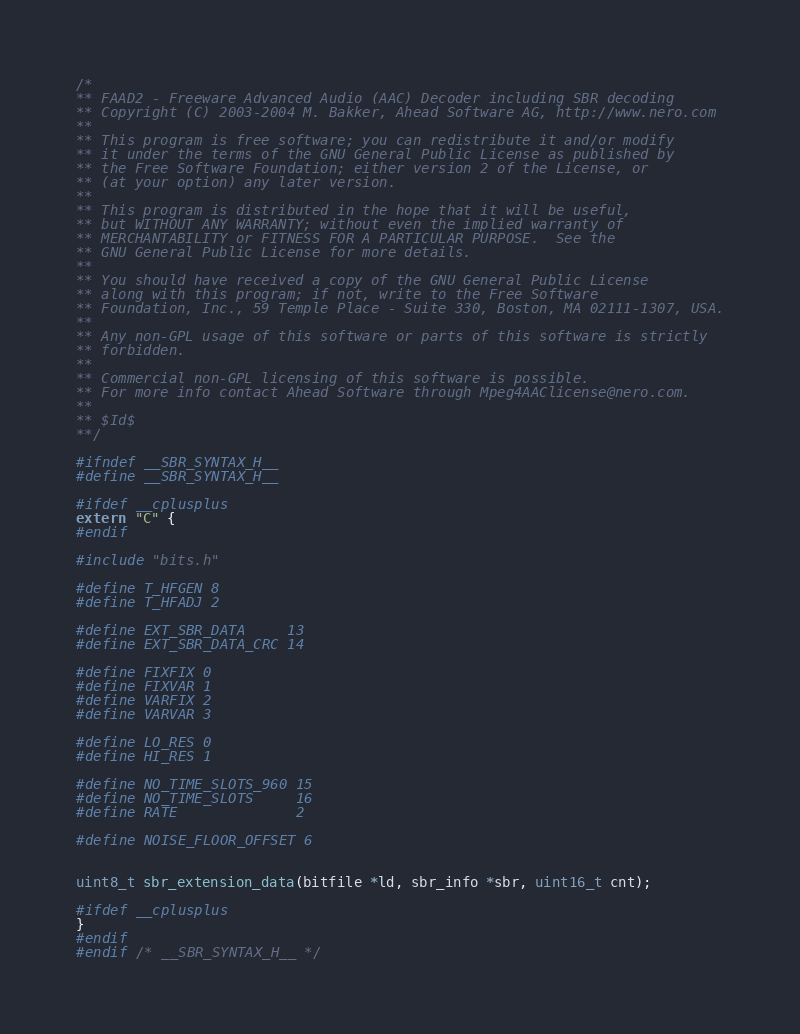<code> <loc_0><loc_0><loc_500><loc_500><_C_>/*
** FAAD2 - Freeware Advanced Audio (AAC) Decoder including SBR decoding
** Copyright (C) 2003-2004 M. Bakker, Ahead Software AG, http://www.nero.com
**  
** This program is free software; you can redistribute it and/or modify
** it under the terms of the GNU General Public License as published by
** the Free Software Foundation; either version 2 of the License, or
** (at your option) any later version.
** 
** This program is distributed in the hope that it will be useful,
** but WITHOUT ANY WARRANTY; without even the implied warranty of
** MERCHANTABILITY or FITNESS FOR A PARTICULAR PURPOSE.  See the
** GNU General Public License for more details.
** 
** You should have received a copy of the GNU General Public License
** along with this program; if not, write to the Free Software 
** Foundation, Inc., 59 Temple Place - Suite 330, Boston, MA 02111-1307, USA.
**
** Any non-GPL usage of this software or parts of this software is strictly
** forbidden.
**
** Commercial non-GPL licensing of this software is possible.
** For more info contact Ahead Software through Mpeg4AAClicense@nero.com.
**
** $Id$
**/

#ifndef __SBR_SYNTAX_H__
#define __SBR_SYNTAX_H__

#ifdef __cplusplus
extern "C" {
#endif

#include "bits.h"

#define T_HFGEN 8
#define T_HFADJ 2

#define EXT_SBR_DATA     13
#define EXT_SBR_DATA_CRC 14

#define FIXFIX 0
#define FIXVAR 1
#define VARFIX 2
#define VARVAR 3

#define LO_RES 0
#define HI_RES 1

#define NO_TIME_SLOTS_960 15
#define NO_TIME_SLOTS     16
#define RATE              2

#define NOISE_FLOOR_OFFSET 6


uint8_t sbr_extension_data(bitfile *ld, sbr_info *sbr, uint16_t cnt);

#ifdef __cplusplus
}
#endif
#endif /* __SBR_SYNTAX_H__ */

</code> 